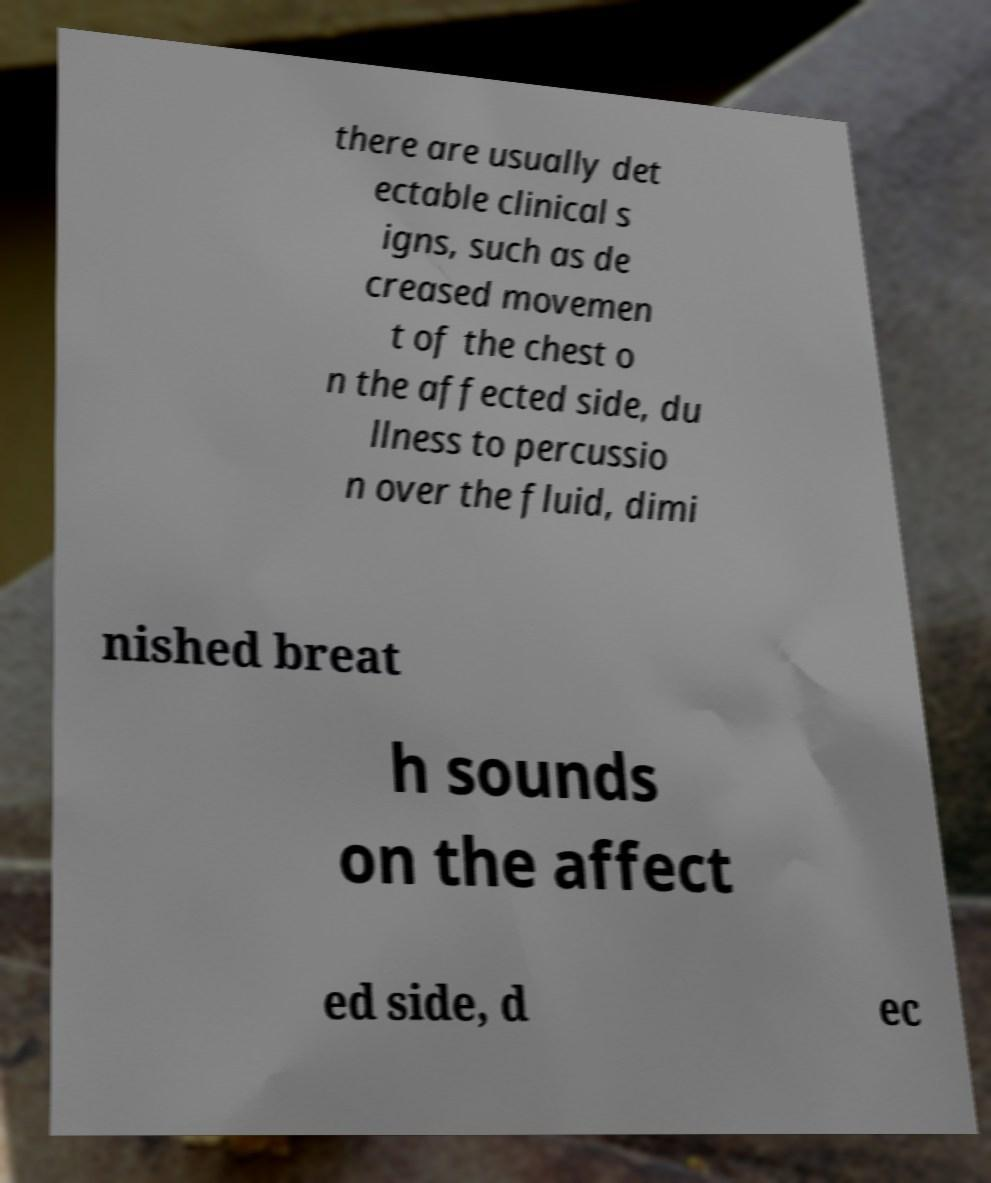There's text embedded in this image that I need extracted. Can you transcribe it verbatim? there are usually det ectable clinical s igns, such as de creased movemen t of the chest o n the affected side, du llness to percussio n over the fluid, dimi nished breat h sounds on the affect ed side, d ec 